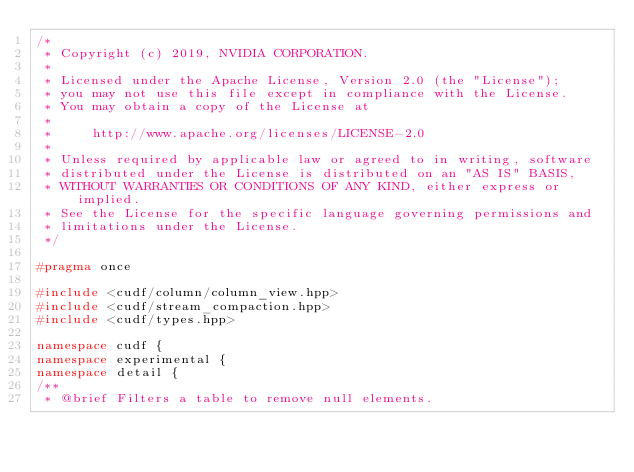Convert code to text. <code><loc_0><loc_0><loc_500><loc_500><_C++_>/*
 * Copyright (c) 2019, NVIDIA CORPORATION.
 *
 * Licensed under the Apache License, Version 2.0 (the "License");
 * you may not use this file except in compliance with the License.
 * You may obtain a copy of the License at
 *
 *     http://www.apache.org/licenses/LICENSE-2.0
 *
 * Unless required by applicable law or agreed to in writing, software
 * distributed under the License is distributed on an "AS IS" BASIS,
 * WITHOUT WARRANTIES OR CONDITIONS OF ANY KIND, either express or implied.
 * See the License for the specific language governing permissions and
 * limitations under the License.
 */

#pragma once

#include <cudf/column/column_view.hpp>
#include <cudf/stream_compaction.hpp>
#include <cudf/types.hpp>

namespace cudf {
namespace experimental {
namespace detail {
/**
 * @brief Filters a table to remove null elements.</code> 